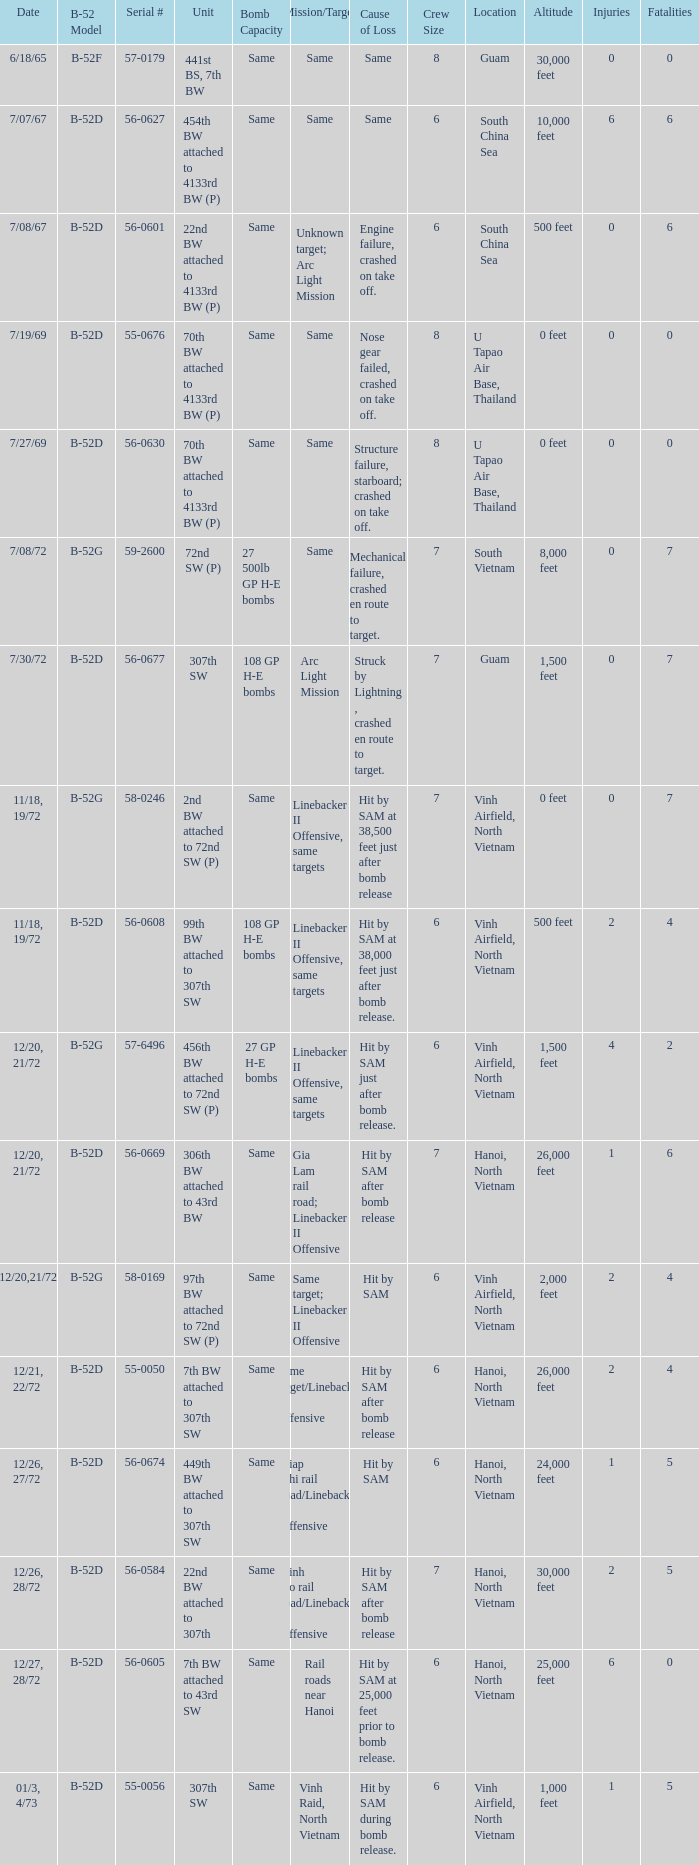When  27 gp h-e bombs the capacity of the bomb what is the cause of loss? Hit by SAM just after bomb release. 